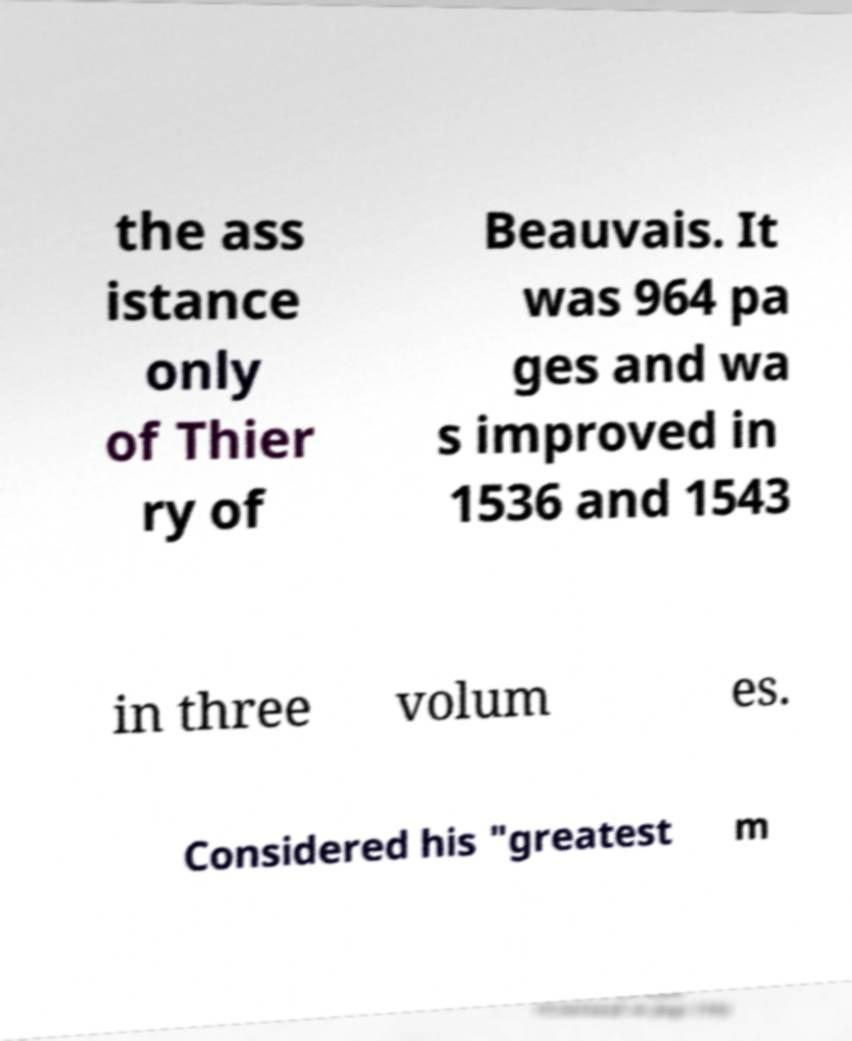I need the written content from this picture converted into text. Can you do that? the ass istance only of Thier ry of Beauvais. It was 964 pa ges and wa s improved in 1536 and 1543 in three volum es. Considered his "greatest m 